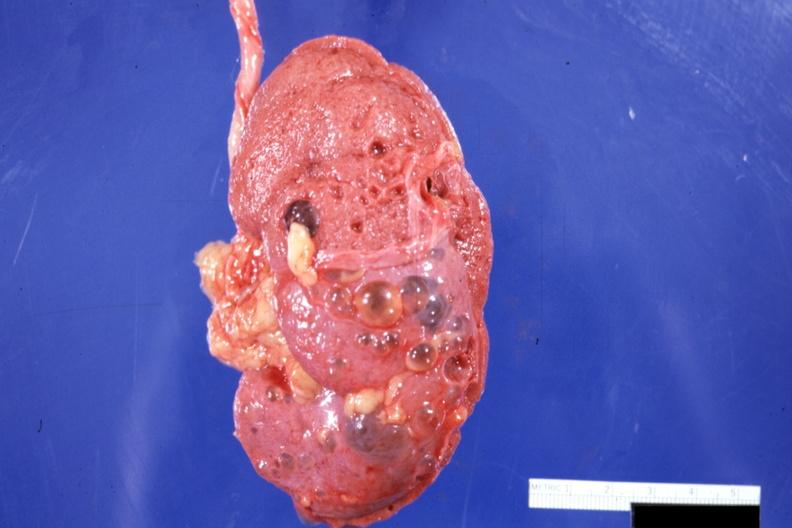how does this image show external view?
Answer the question using a single word or phrase. With capsule stripped 